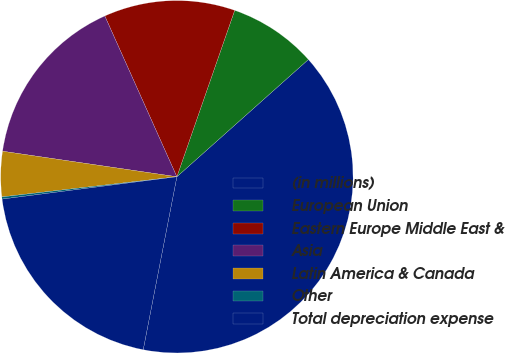<chart> <loc_0><loc_0><loc_500><loc_500><pie_chart><fcel>(in millions)<fcel>European Union<fcel>Eastern Europe Middle East &<fcel>Asia<fcel>Latin America & Canada<fcel>Other<fcel>Total depreciation expense<nl><fcel>39.65%<fcel>8.09%<fcel>12.03%<fcel>15.98%<fcel>4.14%<fcel>0.2%<fcel>19.92%<nl></chart> 